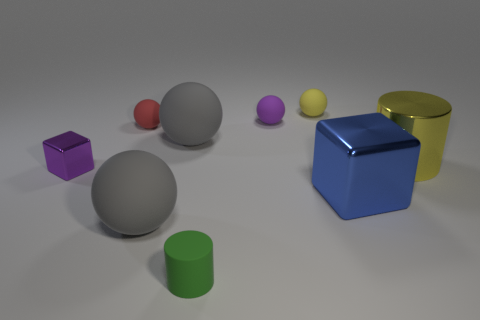How many gray spheres must be subtracted to get 1 gray spheres? 1 Subtract all tiny yellow spheres. How many spheres are left? 4 Add 1 small green things. How many objects exist? 10 Subtract all cyan blocks. How many gray spheres are left? 2 Subtract 1 cubes. How many cubes are left? 1 Subtract all cylinders. How many objects are left? 7 Subtract all red balls. How many balls are left? 4 Subtract 0 brown blocks. How many objects are left? 9 Subtract all blue cylinders. Subtract all purple cubes. How many cylinders are left? 2 Subtract all yellow metal cylinders. Subtract all yellow metal cylinders. How many objects are left? 7 